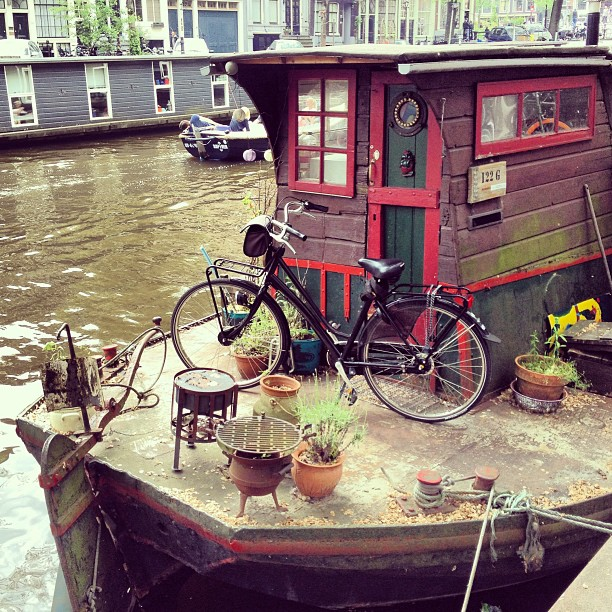Please provide the bounding box coordinate of the region this sentence describes: a small grill set. To precisely identify the small grill set, the bounding box would be [0.34, 0.66, 0.5, 0.87], focusing on the grill at the forefront of a charming houseboat scene. 